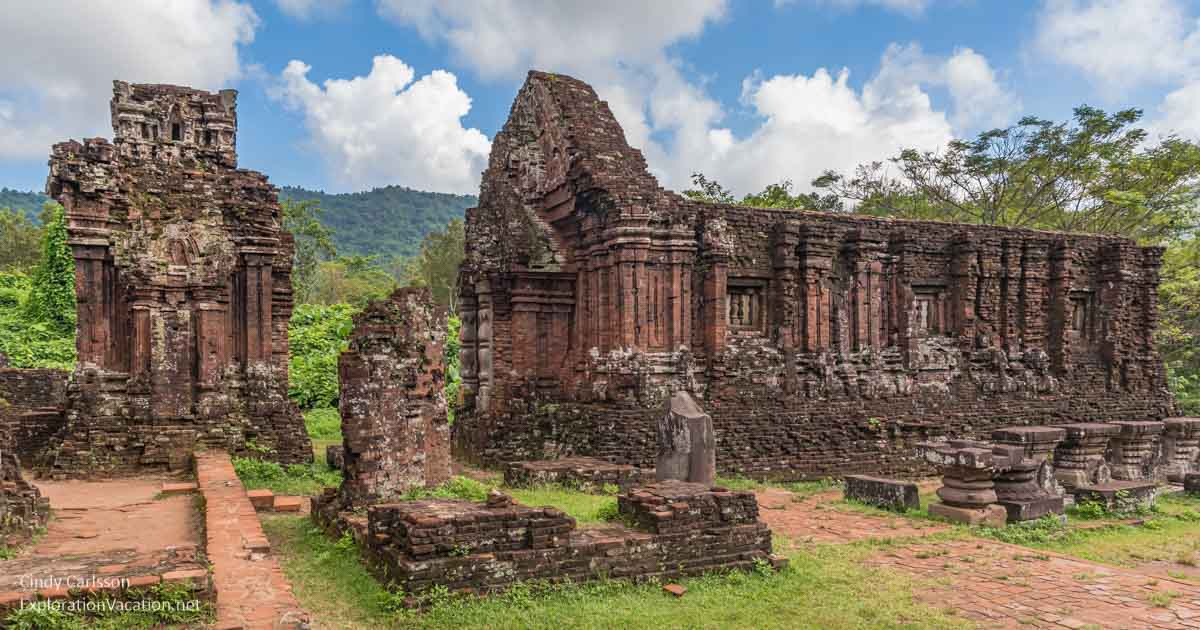Can you describe the history behind this temple complex? The My Son temple complex, located in the Quang Nam province of Vietnam, is a cluster of abandoned and partially ruined Hindu temples built between the 4th and 14th centuries AD by the kings of Champa. These temples, dedicated to the worship of Shiva, played a significant role in the spiritual and political life of the Champa kingdom. Over the centuries, the complex witnessed various phases of construction, resulting in a blend of architectural styles. Today, it stands as a testament to the region's rich cultural and religious history, drawing visitors and scholars from around the world to marvel at its historic significance and architectural beauty. 